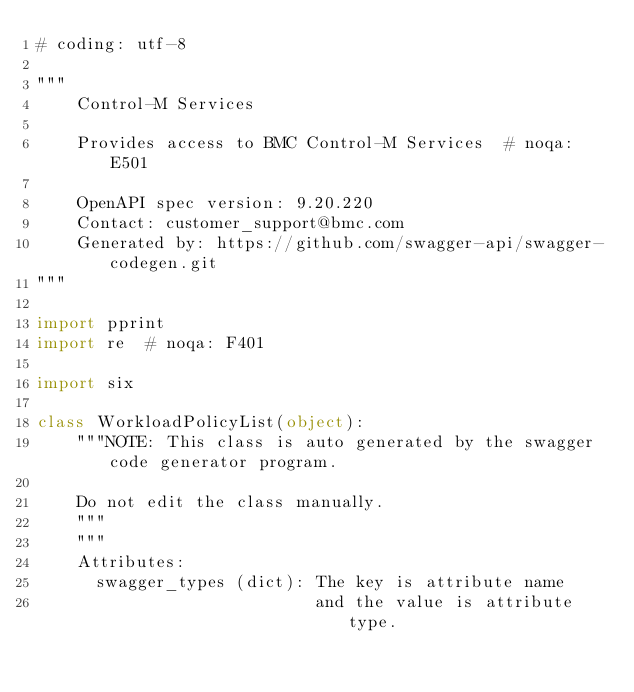Convert code to text. <code><loc_0><loc_0><loc_500><loc_500><_Python_># coding: utf-8

"""
    Control-M Services

    Provides access to BMC Control-M Services  # noqa: E501

    OpenAPI spec version: 9.20.220
    Contact: customer_support@bmc.com
    Generated by: https://github.com/swagger-api/swagger-codegen.git
"""

import pprint
import re  # noqa: F401

import six

class WorkloadPolicyList(object):
    """NOTE: This class is auto generated by the swagger code generator program.

    Do not edit the class manually.
    """
    """
    Attributes:
      swagger_types (dict): The key is attribute name
                            and the value is attribute type.</code> 